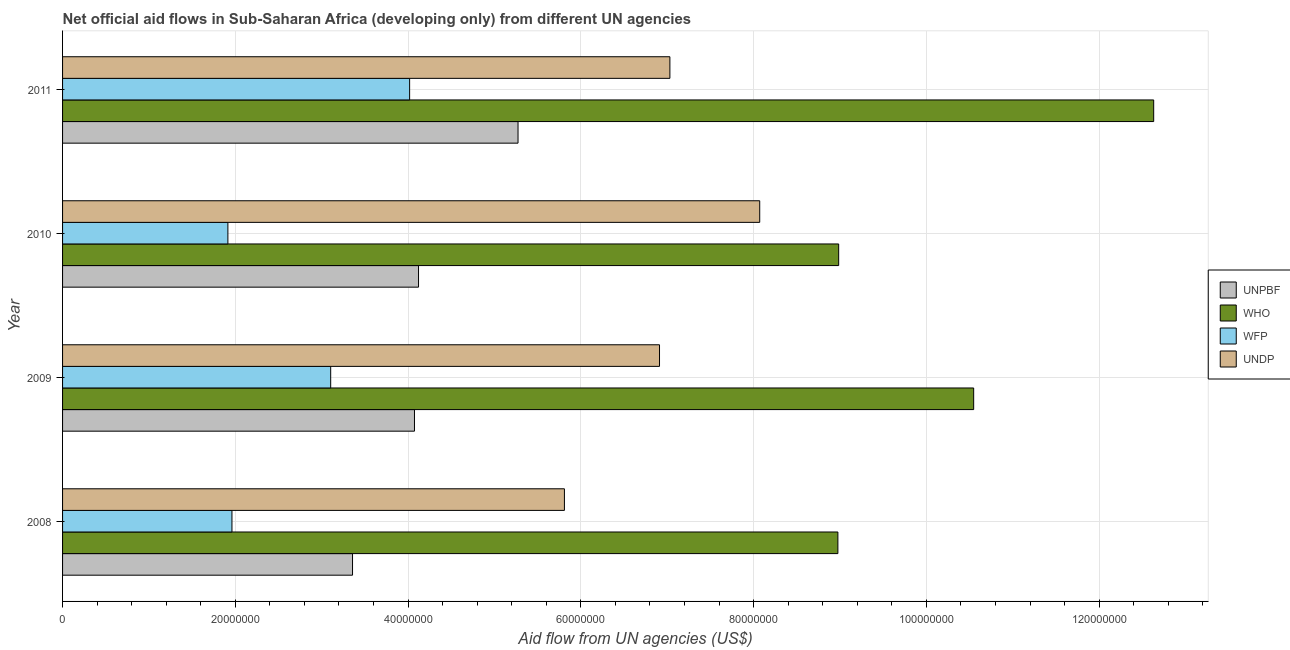How many groups of bars are there?
Your response must be concise. 4. What is the label of the 2nd group of bars from the top?
Ensure brevity in your answer.  2010. What is the amount of aid given by wfp in 2010?
Give a very brief answer. 1.91e+07. Across all years, what is the maximum amount of aid given by undp?
Offer a terse response. 8.07e+07. Across all years, what is the minimum amount of aid given by wfp?
Offer a terse response. 1.91e+07. In which year was the amount of aid given by who maximum?
Give a very brief answer. 2011. What is the total amount of aid given by who in the graph?
Your answer should be compact. 4.11e+08. What is the difference between the amount of aid given by undp in 2009 and that in 2011?
Give a very brief answer. -1.20e+06. What is the difference between the amount of aid given by who in 2009 and the amount of aid given by unpbf in 2010?
Your response must be concise. 6.43e+07. What is the average amount of aid given by who per year?
Your response must be concise. 1.03e+08. In the year 2010, what is the difference between the amount of aid given by who and amount of aid given by unpbf?
Your response must be concise. 4.86e+07. What is the ratio of the amount of aid given by undp in 2008 to that in 2011?
Provide a succinct answer. 0.83. What is the difference between the highest and the second highest amount of aid given by undp?
Provide a short and direct response. 1.04e+07. What is the difference between the highest and the lowest amount of aid given by who?
Give a very brief answer. 3.66e+07. What does the 3rd bar from the top in 2009 represents?
Make the answer very short. WHO. What does the 2nd bar from the bottom in 2009 represents?
Your answer should be compact. WHO. Is it the case that in every year, the sum of the amount of aid given by unpbf and amount of aid given by who is greater than the amount of aid given by wfp?
Provide a short and direct response. Yes. What is the difference between two consecutive major ticks on the X-axis?
Ensure brevity in your answer.  2.00e+07. Are the values on the major ticks of X-axis written in scientific E-notation?
Offer a very short reply. No. Does the graph contain any zero values?
Keep it short and to the point. No. Where does the legend appear in the graph?
Provide a succinct answer. Center right. How many legend labels are there?
Offer a very short reply. 4. How are the legend labels stacked?
Your answer should be compact. Vertical. What is the title of the graph?
Make the answer very short. Net official aid flows in Sub-Saharan Africa (developing only) from different UN agencies. What is the label or title of the X-axis?
Your answer should be compact. Aid flow from UN agencies (US$). What is the label or title of the Y-axis?
Your answer should be compact. Year. What is the Aid flow from UN agencies (US$) of UNPBF in 2008?
Ensure brevity in your answer.  3.36e+07. What is the Aid flow from UN agencies (US$) in WHO in 2008?
Keep it short and to the point. 8.98e+07. What is the Aid flow from UN agencies (US$) in WFP in 2008?
Keep it short and to the point. 1.96e+07. What is the Aid flow from UN agencies (US$) in UNDP in 2008?
Ensure brevity in your answer.  5.81e+07. What is the Aid flow from UN agencies (US$) in UNPBF in 2009?
Keep it short and to the point. 4.07e+07. What is the Aid flow from UN agencies (US$) in WHO in 2009?
Offer a terse response. 1.05e+08. What is the Aid flow from UN agencies (US$) of WFP in 2009?
Your response must be concise. 3.10e+07. What is the Aid flow from UN agencies (US$) of UNDP in 2009?
Provide a succinct answer. 6.91e+07. What is the Aid flow from UN agencies (US$) in UNPBF in 2010?
Your response must be concise. 4.12e+07. What is the Aid flow from UN agencies (US$) of WHO in 2010?
Your answer should be compact. 8.98e+07. What is the Aid flow from UN agencies (US$) in WFP in 2010?
Ensure brevity in your answer.  1.91e+07. What is the Aid flow from UN agencies (US$) of UNDP in 2010?
Your answer should be very brief. 8.07e+07. What is the Aid flow from UN agencies (US$) of UNPBF in 2011?
Your answer should be very brief. 5.27e+07. What is the Aid flow from UN agencies (US$) in WHO in 2011?
Provide a short and direct response. 1.26e+08. What is the Aid flow from UN agencies (US$) in WFP in 2011?
Give a very brief answer. 4.02e+07. What is the Aid flow from UN agencies (US$) of UNDP in 2011?
Give a very brief answer. 7.03e+07. Across all years, what is the maximum Aid flow from UN agencies (US$) in UNPBF?
Offer a terse response. 5.27e+07. Across all years, what is the maximum Aid flow from UN agencies (US$) in WHO?
Provide a short and direct response. 1.26e+08. Across all years, what is the maximum Aid flow from UN agencies (US$) in WFP?
Give a very brief answer. 4.02e+07. Across all years, what is the maximum Aid flow from UN agencies (US$) in UNDP?
Make the answer very short. 8.07e+07. Across all years, what is the minimum Aid flow from UN agencies (US$) of UNPBF?
Offer a terse response. 3.36e+07. Across all years, what is the minimum Aid flow from UN agencies (US$) in WHO?
Keep it short and to the point. 8.98e+07. Across all years, what is the minimum Aid flow from UN agencies (US$) in WFP?
Your answer should be very brief. 1.91e+07. Across all years, what is the minimum Aid flow from UN agencies (US$) of UNDP?
Ensure brevity in your answer.  5.81e+07. What is the total Aid flow from UN agencies (US$) in UNPBF in the graph?
Make the answer very short. 1.68e+08. What is the total Aid flow from UN agencies (US$) in WHO in the graph?
Provide a short and direct response. 4.11e+08. What is the total Aid flow from UN agencies (US$) of WFP in the graph?
Provide a short and direct response. 1.10e+08. What is the total Aid flow from UN agencies (US$) in UNDP in the graph?
Your answer should be very brief. 2.78e+08. What is the difference between the Aid flow from UN agencies (US$) in UNPBF in 2008 and that in 2009?
Provide a short and direct response. -7.17e+06. What is the difference between the Aid flow from UN agencies (US$) in WHO in 2008 and that in 2009?
Your answer should be compact. -1.57e+07. What is the difference between the Aid flow from UN agencies (US$) of WFP in 2008 and that in 2009?
Offer a terse response. -1.14e+07. What is the difference between the Aid flow from UN agencies (US$) in UNDP in 2008 and that in 2009?
Provide a short and direct response. -1.10e+07. What is the difference between the Aid flow from UN agencies (US$) of UNPBF in 2008 and that in 2010?
Offer a terse response. -7.64e+06. What is the difference between the Aid flow from UN agencies (US$) of WHO in 2008 and that in 2010?
Ensure brevity in your answer.  -9.00e+04. What is the difference between the Aid flow from UN agencies (US$) in WFP in 2008 and that in 2010?
Offer a terse response. 4.70e+05. What is the difference between the Aid flow from UN agencies (US$) of UNDP in 2008 and that in 2010?
Offer a very short reply. -2.26e+07. What is the difference between the Aid flow from UN agencies (US$) of UNPBF in 2008 and that in 2011?
Provide a succinct answer. -1.92e+07. What is the difference between the Aid flow from UN agencies (US$) in WHO in 2008 and that in 2011?
Your response must be concise. -3.66e+07. What is the difference between the Aid flow from UN agencies (US$) in WFP in 2008 and that in 2011?
Keep it short and to the point. -2.06e+07. What is the difference between the Aid flow from UN agencies (US$) of UNDP in 2008 and that in 2011?
Offer a terse response. -1.22e+07. What is the difference between the Aid flow from UN agencies (US$) in UNPBF in 2009 and that in 2010?
Make the answer very short. -4.70e+05. What is the difference between the Aid flow from UN agencies (US$) of WHO in 2009 and that in 2010?
Make the answer very short. 1.56e+07. What is the difference between the Aid flow from UN agencies (US$) of WFP in 2009 and that in 2010?
Provide a succinct answer. 1.19e+07. What is the difference between the Aid flow from UN agencies (US$) in UNDP in 2009 and that in 2010?
Ensure brevity in your answer.  -1.16e+07. What is the difference between the Aid flow from UN agencies (US$) of UNPBF in 2009 and that in 2011?
Offer a very short reply. -1.20e+07. What is the difference between the Aid flow from UN agencies (US$) of WHO in 2009 and that in 2011?
Provide a succinct answer. -2.08e+07. What is the difference between the Aid flow from UN agencies (US$) in WFP in 2009 and that in 2011?
Provide a succinct answer. -9.14e+06. What is the difference between the Aid flow from UN agencies (US$) in UNDP in 2009 and that in 2011?
Provide a short and direct response. -1.20e+06. What is the difference between the Aid flow from UN agencies (US$) of UNPBF in 2010 and that in 2011?
Ensure brevity in your answer.  -1.15e+07. What is the difference between the Aid flow from UN agencies (US$) of WHO in 2010 and that in 2011?
Make the answer very short. -3.65e+07. What is the difference between the Aid flow from UN agencies (US$) in WFP in 2010 and that in 2011?
Provide a short and direct response. -2.10e+07. What is the difference between the Aid flow from UN agencies (US$) of UNDP in 2010 and that in 2011?
Make the answer very short. 1.04e+07. What is the difference between the Aid flow from UN agencies (US$) of UNPBF in 2008 and the Aid flow from UN agencies (US$) of WHO in 2009?
Ensure brevity in your answer.  -7.19e+07. What is the difference between the Aid flow from UN agencies (US$) of UNPBF in 2008 and the Aid flow from UN agencies (US$) of WFP in 2009?
Your answer should be compact. 2.53e+06. What is the difference between the Aid flow from UN agencies (US$) in UNPBF in 2008 and the Aid flow from UN agencies (US$) in UNDP in 2009?
Offer a very short reply. -3.55e+07. What is the difference between the Aid flow from UN agencies (US$) of WHO in 2008 and the Aid flow from UN agencies (US$) of WFP in 2009?
Your response must be concise. 5.87e+07. What is the difference between the Aid flow from UN agencies (US$) of WHO in 2008 and the Aid flow from UN agencies (US$) of UNDP in 2009?
Make the answer very short. 2.06e+07. What is the difference between the Aid flow from UN agencies (US$) of WFP in 2008 and the Aid flow from UN agencies (US$) of UNDP in 2009?
Your answer should be very brief. -4.95e+07. What is the difference between the Aid flow from UN agencies (US$) of UNPBF in 2008 and the Aid flow from UN agencies (US$) of WHO in 2010?
Keep it short and to the point. -5.63e+07. What is the difference between the Aid flow from UN agencies (US$) of UNPBF in 2008 and the Aid flow from UN agencies (US$) of WFP in 2010?
Your answer should be compact. 1.44e+07. What is the difference between the Aid flow from UN agencies (US$) of UNPBF in 2008 and the Aid flow from UN agencies (US$) of UNDP in 2010?
Provide a succinct answer. -4.71e+07. What is the difference between the Aid flow from UN agencies (US$) of WHO in 2008 and the Aid flow from UN agencies (US$) of WFP in 2010?
Provide a succinct answer. 7.06e+07. What is the difference between the Aid flow from UN agencies (US$) of WHO in 2008 and the Aid flow from UN agencies (US$) of UNDP in 2010?
Give a very brief answer. 9.05e+06. What is the difference between the Aid flow from UN agencies (US$) of WFP in 2008 and the Aid flow from UN agencies (US$) of UNDP in 2010?
Keep it short and to the point. -6.11e+07. What is the difference between the Aid flow from UN agencies (US$) of UNPBF in 2008 and the Aid flow from UN agencies (US$) of WHO in 2011?
Make the answer very short. -9.28e+07. What is the difference between the Aid flow from UN agencies (US$) of UNPBF in 2008 and the Aid flow from UN agencies (US$) of WFP in 2011?
Offer a very short reply. -6.61e+06. What is the difference between the Aid flow from UN agencies (US$) in UNPBF in 2008 and the Aid flow from UN agencies (US$) in UNDP in 2011?
Make the answer very short. -3.67e+07. What is the difference between the Aid flow from UN agencies (US$) of WHO in 2008 and the Aid flow from UN agencies (US$) of WFP in 2011?
Your answer should be compact. 4.96e+07. What is the difference between the Aid flow from UN agencies (US$) in WHO in 2008 and the Aid flow from UN agencies (US$) in UNDP in 2011?
Give a very brief answer. 1.94e+07. What is the difference between the Aid flow from UN agencies (US$) in WFP in 2008 and the Aid flow from UN agencies (US$) in UNDP in 2011?
Offer a very short reply. -5.07e+07. What is the difference between the Aid flow from UN agencies (US$) in UNPBF in 2009 and the Aid flow from UN agencies (US$) in WHO in 2010?
Keep it short and to the point. -4.91e+07. What is the difference between the Aid flow from UN agencies (US$) in UNPBF in 2009 and the Aid flow from UN agencies (US$) in WFP in 2010?
Keep it short and to the point. 2.16e+07. What is the difference between the Aid flow from UN agencies (US$) in UNPBF in 2009 and the Aid flow from UN agencies (US$) in UNDP in 2010?
Provide a short and direct response. -4.00e+07. What is the difference between the Aid flow from UN agencies (US$) of WHO in 2009 and the Aid flow from UN agencies (US$) of WFP in 2010?
Provide a succinct answer. 8.63e+07. What is the difference between the Aid flow from UN agencies (US$) of WHO in 2009 and the Aid flow from UN agencies (US$) of UNDP in 2010?
Make the answer very short. 2.48e+07. What is the difference between the Aid flow from UN agencies (US$) of WFP in 2009 and the Aid flow from UN agencies (US$) of UNDP in 2010?
Provide a succinct answer. -4.97e+07. What is the difference between the Aid flow from UN agencies (US$) in UNPBF in 2009 and the Aid flow from UN agencies (US$) in WHO in 2011?
Your answer should be very brief. -8.56e+07. What is the difference between the Aid flow from UN agencies (US$) of UNPBF in 2009 and the Aid flow from UN agencies (US$) of WFP in 2011?
Your response must be concise. 5.60e+05. What is the difference between the Aid flow from UN agencies (US$) of UNPBF in 2009 and the Aid flow from UN agencies (US$) of UNDP in 2011?
Ensure brevity in your answer.  -2.96e+07. What is the difference between the Aid flow from UN agencies (US$) of WHO in 2009 and the Aid flow from UN agencies (US$) of WFP in 2011?
Give a very brief answer. 6.53e+07. What is the difference between the Aid flow from UN agencies (US$) in WHO in 2009 and the Aid flow from UN agencies (US$) in UNDP in 2011?
Your answer should be compact. 3.52e+07. What is the difference between the Aid flow from UN agencies (US$) of WFP in 2009 and the Aid flow from UN agencies (US$) of UNDP in 2011?
Ensure brevity in your answer.  -3.93e+07. What is the difference between the Aid flow from UN agencies (US$) of UNPBF in 2010 and the Aid flow from UN agencies (US$) of WHO in 2011?
Provide a short and direct response. -8.51e+07. What is the difference between the Aid flow from UN agencies (US$) in UNPBF in 2010 and the Aid flow from UN agencies (US$) in WFP in 2011?
Make the answer very short. 1.03e+06. What is the difference between the Aid flow from UN agencies (US$) in UNPBF in 2010 and the Aid flow from UN agencies (US$) in UNDP in 2011?
Your answer should be compact. -2.91e+07. What is the difference between the Aid flow from UN agencies (US$) of WHO in 2010 and the Aid flow from UN agencies (US$) of WFP in 2011?
Give a very brief answer. 4.97e+07. What is the difference between the Aid flow from UN agencies (US$) in WHO in 2010 and the Aid flow from UN agencies (US$) in UNDP in 2011?
Offer a terse response. 1.95e+07. What is the difference between the Aid flow from UN agencies (US$) of WFP in 2010 and the Aid flow from UN agencies (US$) of UNDP in 2011?
Provide a short and direct response. -5.12e+07. What is the average Aid flow from UN agencies (US$) of UNPBF per year?
Provide a succinct answer. 4.21e+07. What is the average Aid flow from UN agencies (US$) in WHO per year?
Make the answer very short. 1.03e+08. What is the average Aid flow from UN agencies (US$) of WFP per year?
Offer a terse response. 2.75e+07. What is the average Aid flow from UN agencies (US$) in UNDP per year?
Give a very brief answer. 6.96e+07. In the year 2008, what is the difference between the Aid flow from UN agencies (US$) in UNPBF and Aid flow from UN agencies (US$) in WHO?
Your answer should be compact. -5.62e+07. In the year 2008, what is the difference between the Aid flow from UN agencies (US$) in UNPBF and Aid flow from UN agencies (US$) in WFP?
Your answer should be compact. 1.40e+07. In the year 2008, what is the difference between the Aid flow from UN agencies (US$) in UNPBF and Aid flow from UN agencies (US$) in UNDP?
Your response must be concise. -2.45e+07. In the year 2008, what is the difference between the Aid flow from UN agencies (US$) of WHO and Aid flow from UN agencies (US$) of WFP?
Offer a very short reply. 7.02e+07. In the year 2008, what is the difference between the Aid flow from UN agencies (US$) in WHO and Aid flow from UN agencies (US$) in UNDP?
Provide a short and direct response. 3.17e+07. In the year 2008, what is the difference between the Aid flow from UN agencies (US$) in WFP and Aid flow from UN agencies (US$) in UNDP?
Offer a terse response. -3.85e+07. In the year 2009, what is the difference between the Aid flow from UN agencies (US$) of UNPBF and Aid flow from UN agencies (US$) of WHO?
Offer a very short reply. -6.47e+07. In the year 2009, what is the difference between the Aid flow from UN agencies (US$) in UNPBF and Aid flow from UN agencies (US$) in WFP?
Provide a succinct answer. 9.70e+06. In the year 2009, what is the difference between the Aid flow from UN agencies (US$) of UNPBF and Aid flow from UN agencies (US$) of UNDP?
Ensure brevity in your answer.  -2.84e+07. In the year 2009, what is the difference between the Aid flow from UN agencies (US$) of WHO and Aid flow from UN agencies (US$) of WFP?
Offer a terse response. 7.44e+07. In the year 2009, what is the difference between the Aid flow from UN agencies (US$) in WHO and Aid flow from UN agencies (US$) in UNDP?
Make the answer very short. 3.64e+07. In the year 2009, what is the difference between the Aid flow from UN agencies (US$) in WFP and Aid flow from UN agencies (US$) in UNDP?
Your answer should be compact. -3.81e+07. In the year 2010, what is the difference between the Aid flow from UN agencies (US$) of UNPBF and Aid flow from UN agencies (US$) of WHO?
Provide a succinct answer. -4.86e+07. In the year 2010, what is the difference between the Aid flow from UN agencies (US$) of UNPBF and Aid flow from UN agencies (US$) of WFP?
Make the answer very short. 2.21e+07. In the year 2010, what is the difference between the Aid flow from UN agencies (US$) in UNPBF and Aid flow from UN agencies (US$) in UNDP?
Give a very brief answer. -3.95e+07. In the year 2010, what is the difference between the Aid flow from UN agencies (US$) of WHO and Aid flow from UN agencies (US$) of WFP?
Ensure brevity in your answer.  7.07e+07. In the year 2010, what is the difference between the Aid flow from UN agencies (US$) in WHO and Aid flow from UN agencies (US$) in UNDP?
Your response must be concise. 9.14e+06. In the year 2010, what is the difference between the Aid flow from UN agencies (US$) of WFP and Aid flow from UN agencies (US$) of UNDP?
Ensure brevity in your answer.  -6.16e+07. In the year 2011, what is the difference between the Aid flow from UN agencies (US$) in UNPBF and Aid flow from UN agencies (US$) in WHO?
Provide a succinct answer. -7.36e+07. In the year 2011, what is the difference between the Aid flow from UN agencies (US$) in UNPBF and Aid flow from UN agencies (US$) in WFP?
Offer a very short reply. 1.26e+07. In the year 2011, what is the difference between the Aid flow from UN agencies (US$) in UNPBF and Aid flow from UN agencies (US$) in UNDP?
Ensure brevity in your answer.  -1.76e+07. In the year 2011, what is the difference between the Aid flow from UN agencies (US$) of WHO and Aid flow from UN agencies (US$) of WFP?
Your response must be concise. 8.61e+07. In the year 2011, what is the difference between the Aid flow from UN agencies (US$) in WHO and Aid flow from UN agencies (US$) in UNDP?
Your response must be concise. 5.60e+07. In the year 2011, what is the difference between the Aid flow from UN agencies (US$) in WFP and Aid flow from UN agencies (US$) in UNDP?
Your response must be concise. -3.01e+07. What is the ratio of the Aid flow from UN agencies (US$) in UNPBF in 2008 to that in 2009?
Keep it short and to the point. 0.82. What is the ratio of the Aid flow from UN agencies (US$) of WHO in 2008 to that in 2009?
Your answer should be compact. 0.85. What is the ratio of the Aid flow from UN agencies (US$) in WFP in 2008 to that in 2009?
Ensure brevity in your answer.  0.63. What is the ratio of the Aid flow from UN agencies (US$) in UNDP in 2008 to that in 2009?
Offer a terse response. 0.84. What is the ratio of the Aid flow from UN agencies (US$) in UNPBF in 2008 to that in 2010?
Provide a succinct answer. 0.81. What is the ratio of the Aid flow from UN agencies (US$) in WHO in 2008 to that in 2010?
Your answer should be very brief. 1. What is the ratio of the Aid flow from UN agencies (US$) of WFP in 2008 to that in 2010?
Make the answer very short. 1.02. What is the ratio of the Aid flow from UN agencies (US$) in UNDP in 2008 to that in 2010?
Offer a terse response. 0.72. What is the ratio of the Aid flow from UN agencies (US$) in UNPBF in 2008 to that in 2011?
Make the answer very short. 0.64. What is the ratio of the Aid flow from UN agencies (US$) in WHO in 2008 to that in 2011?
Offer a terse response. 0.71. What is the ratio of the Aid flow from UN agencies (US$) of WFP in 2008 to that in 2011?
Keep it short and to the point. 0.49. What is the ratio of the Aid flow from UN agencies (US$) in UNDP in 2008 to that in 2011?
Your answer should be very brief. 0.83. What is the ratio of the Aid flow from UN agencies (US$) in UNPBF in 2009 to that in 2010?
Keep it short and to the point. 0.99. What is the ratio of the Aid flow from UN agencies (US$) of WHO in 2009 to that in 2010?
Give a very brief answer. 1.17. What is the ratio of the Aid flow from UN agencies (US$) in WFP in 2009 to that in 2010?
Your answer should be very brief. 1.62. What is the ratio of the Aid flow from UN agencies (US$) of UNDP in 2009 to that in 2010?
Offer a very short reply. 0.86. What is the ratio of the Aid flow from UN agencies (US$) of UNPBF in 2009 to that in 2011?
Your answer should be very brief. 0.77. What is the ratio of the Aid flow from UN agencies (US$) in WHO in 2009 to that in 2011?
Your answer should be very brief. 0.83. What is the ratio of the Aid flow from UN agencies (US$) in WFP in 2009 to that in 2011?
Your answer should be compact. 0.77. What is the ratio of the Aid flow from UN agencies (US$) of UNDP in 2009 to that in 2011?
Your answer should be compact. 0.98. What is the ratio of the Aid flow from UN agencies (US$) in UNPBF in 2010 to that in 2011?
Keep it short and to the point. 0.78. What is the ratio of the Aid flow from UN agencies (US$) of WHO in 2010 to that in 2011?
Keep it short and to the point. 0.71. What is the ratio of the Aid flow from UN agencies (US$) in WFP in 2010 to that in 2011?
Provide a succinct answer. 0.48. What is the ratio of the Aid flow from UN agencies (US$) in UNDP in 2010 to that in 2011?
Keep it short and to the point. 1.15. What is the difference between the highest and the second highest Aid flow from UN agencies (US$) in UNPBF?
Ensure brevity in your answer.  1.15e+07. What is the difference between the highest and the second highest Aid flow from UN agencies (US$) of WHO?
Provide a succinct answer. 2.08e+07. What is the difference between the highest and the second highest Aid flow from UN agencies (US$) in WFP?
Your response must be concise. 9.14e+06. What is the difference between the highest and the second highest Aid flow from UN agencies (US$) of UNDP?
Provide a short and direct response. 1.04e+07. What is the difference between the highest and the lowest Aid flow from UN agencies (US$) in UNPBF?
Your response must be concise. 1.92e+07. What is the difference between the highest and the lowest Aid flow from UN agencies (US$) of WHO?
Offer a very short reply. 3.66e+07. What is the difference between the highest and the lowest Aid flow from UN agencies (US$) in WFP?
Offer a terse response. 2.10e+07. What is the difference between the highest and the lowest Aid flow from UN agencies (US$) of UNDP?
Your response must be concise. 2.26e+07. 